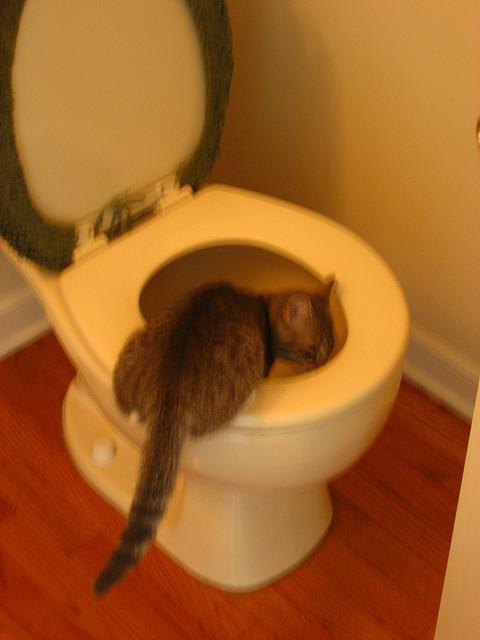Is this a hardwood floor?
Quick response, please. Yes. Is the cat's water dish empty?
Write a very short answer. Yes. Is the cat in the toilet?
Quick response, please. Yes. How safe is it to drink from this fixture?
Keep it brief. Not safe. 